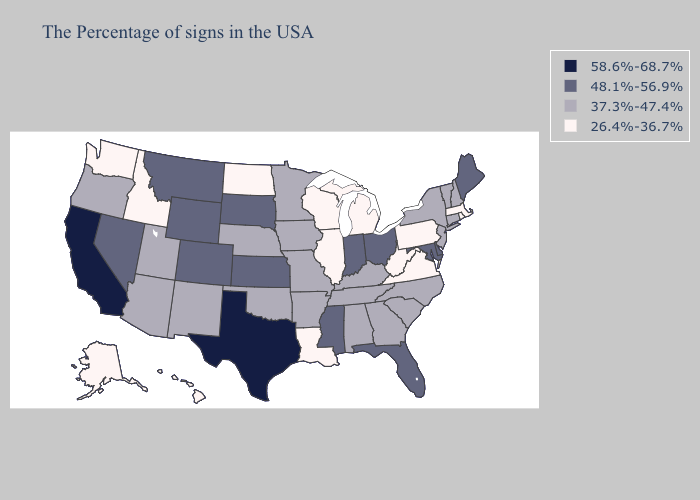Does Mississippi have the lowest value in the USA?
Write a very short answer. No. What is the lowest value in the Northeast?
Keep it brief. 26.4%-36.7%. Among the states that border Iowa , does Wisconsin have the highest value?
Keep it brief. No. Among the states that border Arkansas , which have the lowest value?
Be succinct. Louisiana. Name the states that have a value in the range 26.4%-36.7%?
Give a very brief answer. Massachusetts, Rhode Island, Pennsylvania, Virginia, West Virginia, Michigan, Wisconsin, Illinois, Louisiana, North Dakota, Idaho, Washington, Alaska, Hawaii. Which states hav the highest value in the Northeast?
Write a very short answer. Maine. Does Wisconsin have the lowest value in the USA?
Write a very short answer. Yes. What is the value of Ohio?
Keep it brief. 48.1%-56.9%. Name the states that have a value in the range 48.1%-56.9%?
Write a very short answer. Maine, Delaware, Maryland, Ohio, Florida, Indiana, Mississippi, Kansas, South Dakota, Wyoming, Colorado, Montana, Nevada. What is the highest value in the South ?
Short answer required. 58.6%-68.7%. What is the highest value in the Northeast ?
Short answer required. 48.1%-56.9%. Name the states that have a value in the range 48.1%-56.9%?
Keep it brief. Maine, Delaware, Maryland, Ohio, Florida, Indiana, Mississippi, Kansas, South Dakota, Wyoming, Colorado, Montana, Nevada. Among the states that border West Virginia , does Maryland have the highest value?
Keep it brief. Yes. What is the value of Colorado?
Answer briefly. 48.1%-56.9%. Does Colorado have the same value as Virginia?
Write a very short answer. No. 